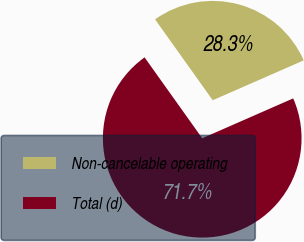Convert chart to OTSL. <chart><loc_0><loc_0><loc_500><loc_500><pie_chart><fcel>Non-cancelable operating<fcel>Total (d)<nl><fcel>28.28%<fcel>71.72%<nl></chart> 